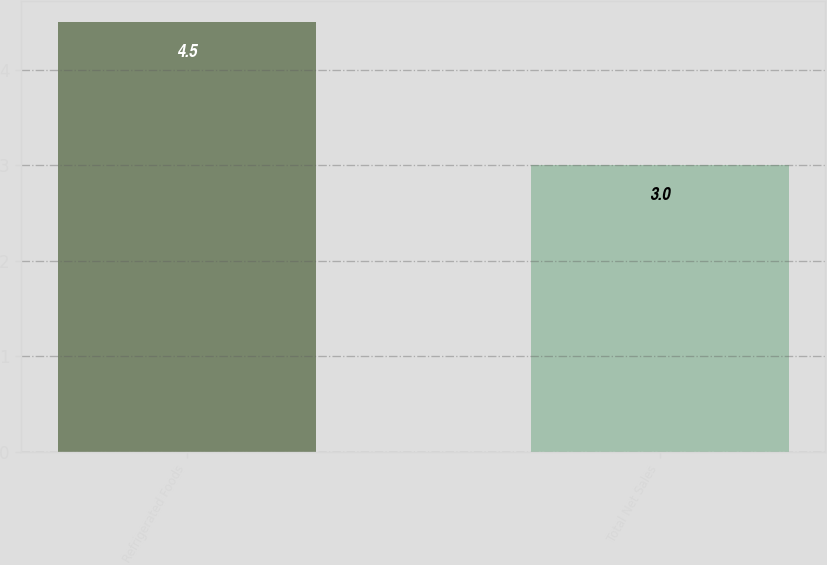Convert chart to OTSL. <chart><loc_0><loc_0><loc_500><loc_500><bar_chart><fcel>Refrigerated Foods<fcel>Total Net Sales<nl><fcel>4.5<fcel>3<nl></chart> 